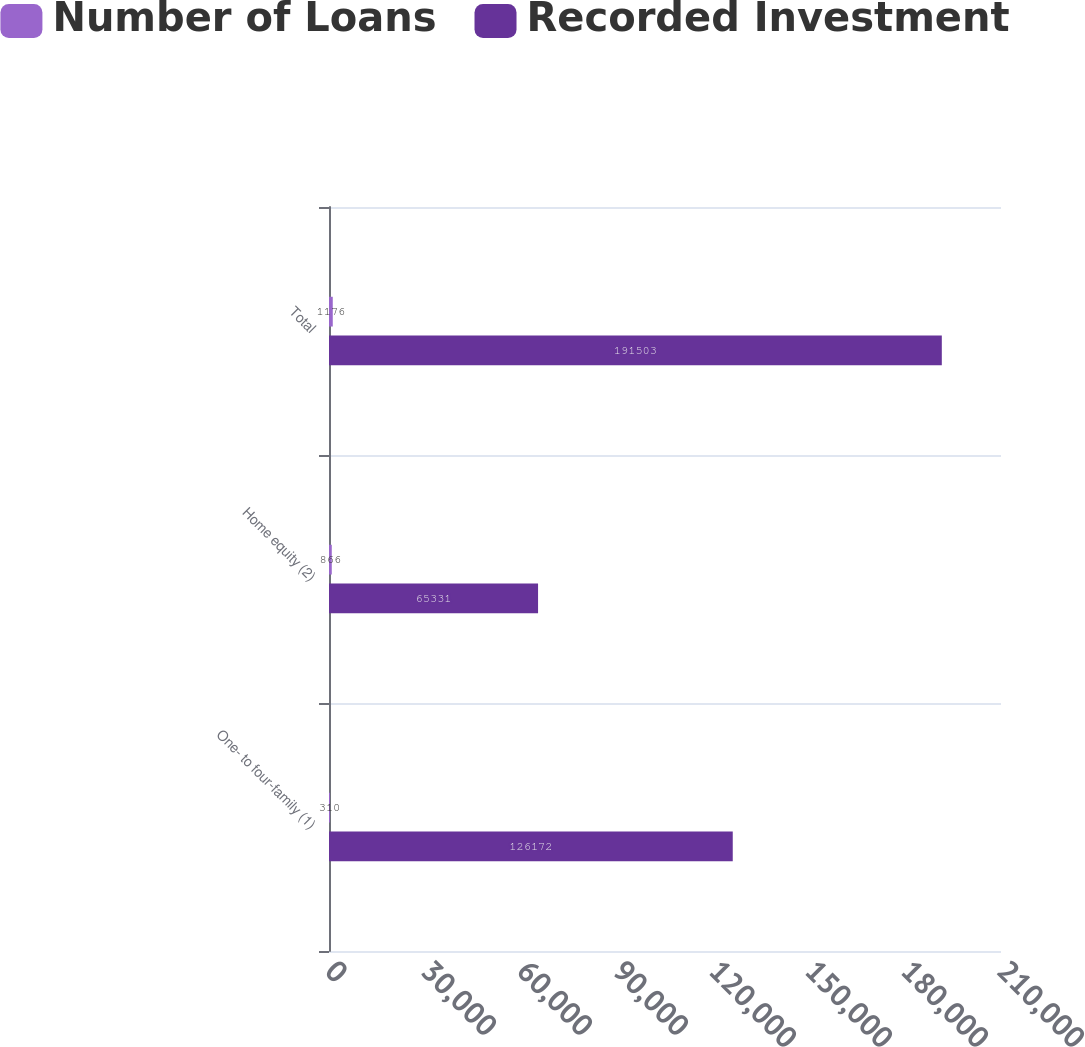Convert chart to OTSL. <chart><loc_0><loc_0><loc_500><loc_500><stacked_bar_chart><ecel><fcel>One- to four-family (1)<fcel>Home equity (2)<fcel>Total<nl><fcel>Number of Loans<fcel>310<fcel>866<fcel>1176<nl><fcel>Recorded Investment<fcel>126172<fcel>65331<fcel>191503<nl></chart> 